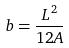<formula> <loc_0><loc_0><loc_500><loc_500>b = \frac { L ^ { 2 } } { 1 2 A }</formula> 